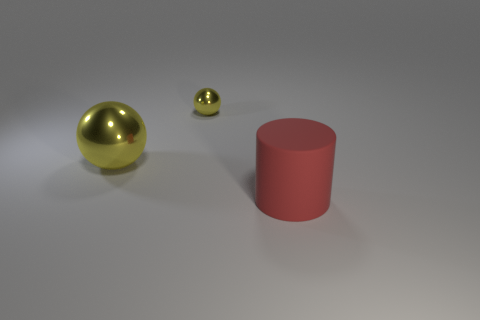What shape is the tiny yellow metal object?
Your answer should be very brief. Sphere. How many large things are red shiny things or yellow metallic spheres?
Make the answer very short. 1. The other yellow shiny thing that is the same shape as the small shiny thing is what size?
Your answer should be compact. Large. How many metal objects are behind the big yellow ball and to the left of the tiny object?
Your answer should be compact. 0. Do the tiny yellow metal thing and the big thing on the left side of the small shiny object have the same shape?
Offer a terse response. Yes. Are there more metal objects to the right of the big shiny object than small brown matte spheres?
Offer a very short reply. Yes. Is the number of large yellow spheres that are to the right of the rubber cylinder less than the number of big yellow metallic spheres?
Make the answer very short. Yes. What number of things are the same color as the tiny ball?
Keep it short and to the point. 1. What material is the thing that is right of the large sphere and behind the big red rubber thing?
Make the answer very short. Metal. There is a large thing behind the red object; is its color the same as the object that is behind the big sphere?
Your answer should be compact. Yes. 